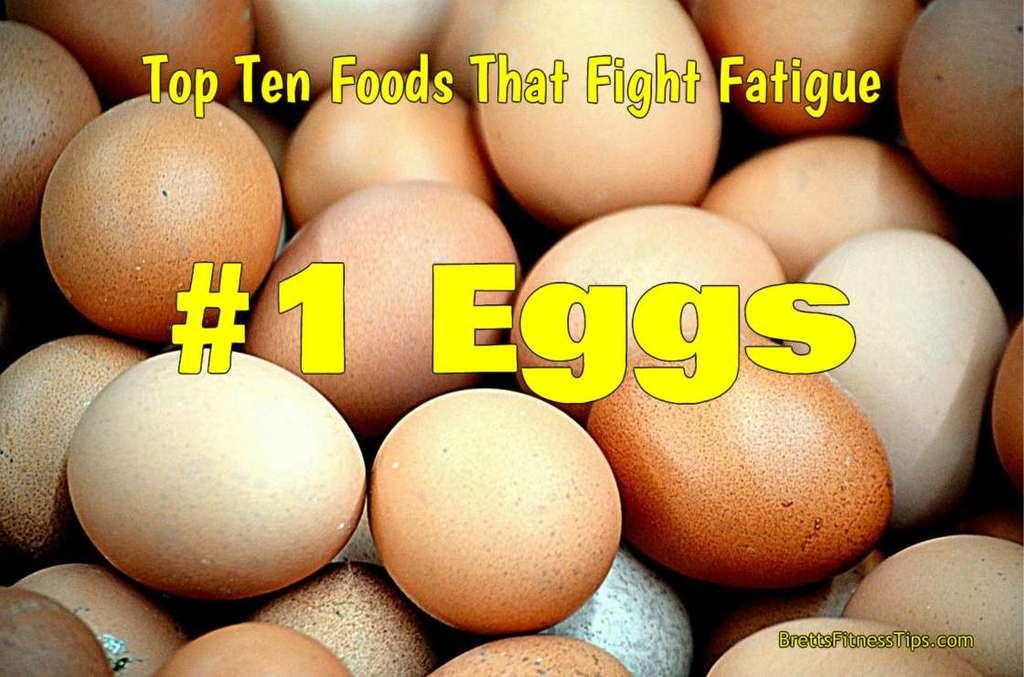What type of eggs are in the picture? There are brown eggs in the picture. Is there any writing or text in the picture? Yes, there is text in the picture. Where is the text located in the picture? The text is located at the bottom right corner of the picture. What type of brass instrument is being played in the picture? There is no brass instrument or any indication of music being played in the picture; it only features brown eggs and text. 